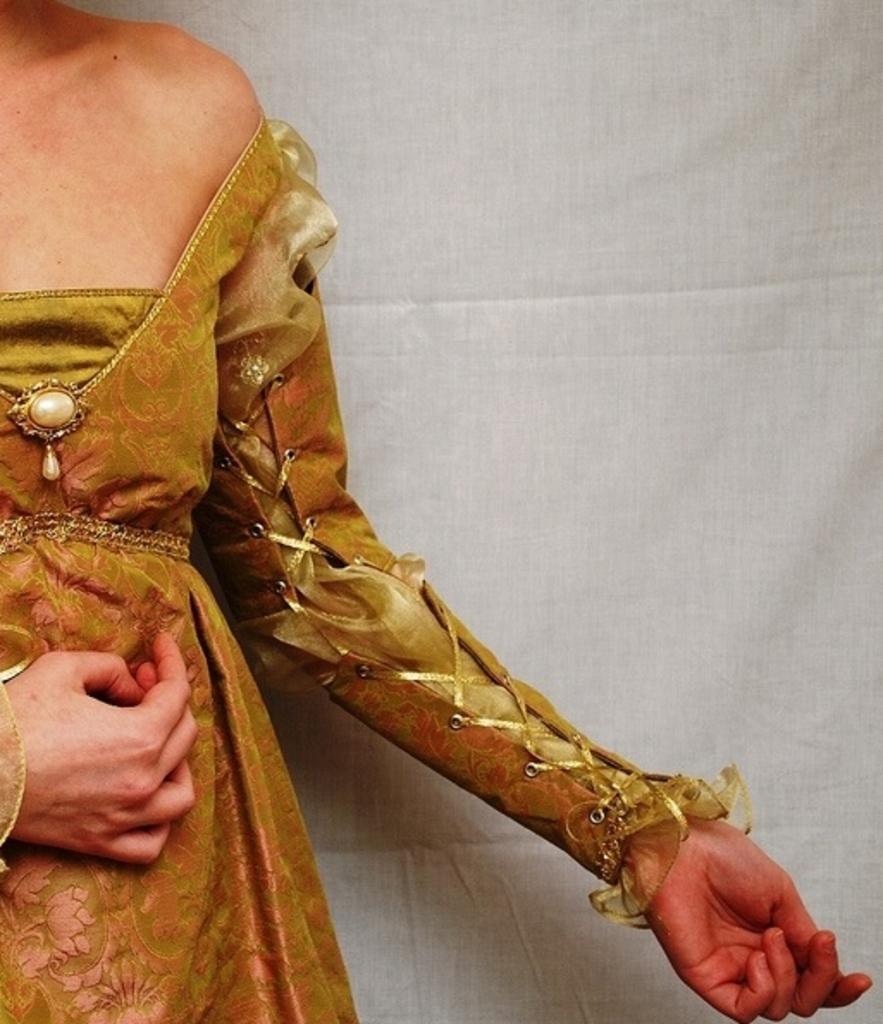How would you summarize this image in a sentence or two? In this picture there is a half image of the woman wearing a brown color beautiful dress. Behind there is a white color fabric curtain. 